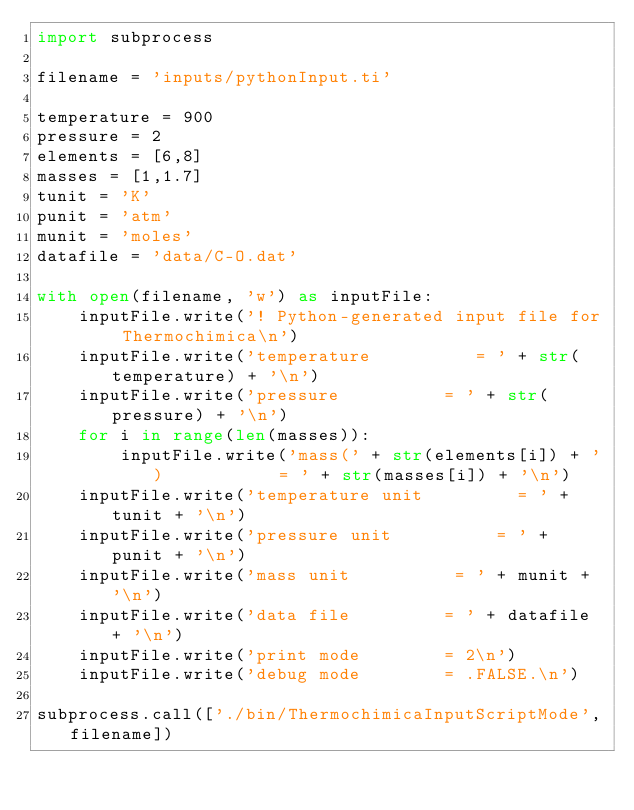<code> <loc_0><loc_0><loc_500><loc_500><_Python_>import subprocess

filename = 'inputs/pythonInput.ti'

temperature = 900
pressure = 2
elements = [6,8]
masses = [1,1.7]
tunit = 'K'
punit = 'atm'
munit = 'moles'
datafile = 'data/C-O.dat'

with open(filename, 'w') as inputFile:
    inputFile.write('! Python-generated input file for Thermochimica\n')
    inputFile.write('temperature          = ' + str(temperature) + '\n')
    inputFile.write('pressure          = ' + str(pressure) + '\n')
    for i in range(len(masses)):
        inputFile.write('mass(' + str(elements[i]) + ')           = ' + str(masses[i]) + '\n')
    inputFile.write('temperature unit         = ' + tunit + '\n')
    inputFile.write('pressure unit          = ' + punit + '\n')
    inputFile.write('mass unit          = ' + munit + '\n')
    inputFile.write('data file         = ' + datafile + '\n')
    inputFile.write('print mode        = 2\n')
    inputFile.write('debug mode        = .FALSE.\n')

subprocess.call(['./bin/ThermochimicaInputScriptMode',filename])
</code> 